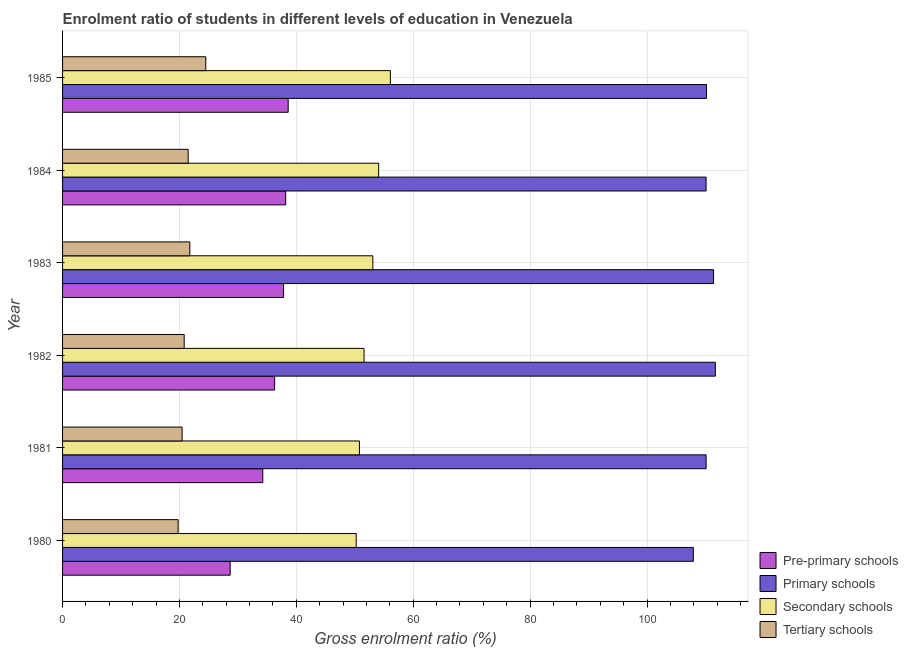How many groups of bars are there?
Provide a short and direct response. 6. How many bars are there on the 2nd tick from the bottom?
Your answer should be very brief. 4. What is the label of the 2nd group of bars from the top?
Your answer should be compact. 1984. What is the gross enrolment ratio in tertiary schools in 1984?
Offer a terse response. 21.5. Across all years, what is the maximum gross enrolment ratio in secondary schools?
Keep it short and to the point. 56.09. Across all years, what is the minimum gross enrolment ratio in tertiary schools?
Offer a very short reply. 19.77. In which year was the gross enrolment ratio in pre-primary schools maximum?
Keep it short and to the point. 1985. In which year was the gross enrolment ratio in pre-primary schools minimum?
Your response must be concise. 1980. What is the total gross enrolment ratio in tertiary schools in the graph?
Offer a very short reply. 128.81. What is the difference between the gross enrolment ratio in secondary schools in 1981 and that in 1983?
Make the answer very short. -2.3. What is the difference between the gross enrolment ratio in pre-primary schools in 1980 and the gross enrolment ratio in primary schools in 1985?
Ensure brevity in your answer.  -81.5. What is the average gross enrolment ratio in primary schools per year?
Your response must be concise. 110.24. In the year 1985, what is the difference between the gross enrolment ratio in tertiary schools and gross enrolment ratio in pre-primary schools?
Provide a succinct answer. -14.1. In how many years, is the gross enrolment ratio in pre-primary schools greater than 24 %?
Your answer should be very brief. 6. What is the ratio of the gross enrolment ratio in pre-primary schools in 1981 to that in 1982?
Offer a very short reply. 0.94. Is the gross enrolment ratio in pre-primary schools in 1981 less than that in 1985?
Provide a succinct answer. Yes. Is the difference between the gross enrolment ratio in pre-primary schools in 1983 and 1984 greater than the difference between the gross enrolment ratio in tertiary schools in 1983 and 1984?
Your answer should be very brief. No. What is the difference between the highest and the second highest gross enrolment ratio in pre-primary schools?
Offer a very short reply. 0.42. What is the difference between the highest and the lowest gross enrolment ratio in tertiary schools?
Give a very brief answer. 4.73. In how many years, is the gross enrolment ratio in pre-primary schools greater than the average gross enrolment ratio in pre-primary schools taken over all years?
Your answer should be compact. 4. What does the 1st bar from the top in 1985 represents?
Provide a succinct answer. Tertiary schools. What does the 3rd bar from the bottom in 1980 represents?
Offer a very short reply. Secondary schools. Are all the bars in the graph horizontal?
Ensure brevity in your answer.  Yes. How many years are there in the graph?
Offer a terse response. 6. What is the difference between two consecutive major ticks on the X-axis?
Make the answer very short. 20. Does the graph contain grids?
Provide a short and direct response. Yes. Where does the legend appear in the graph?
Your answer should be very brief. Bottom right. How are the legend labels stacked?
Keep it short and to the point. Vertical. What is the title of the graph?
Offer a very short reply. Enrolment ratio of students in different levels of education in Venezuela. What is the label or title of the X-axis?
Your answer should be very brief. Gross enrolment ratio (%). What is the label or title of the Y-axis?
Provide a succinct answer. Year. What is the Gross enrolment ratio (%) in Pre-primary schools in 1980?
Make the answer very short. 28.68. What is the Gross enrolment ratio (%) in Primary schools in 1980?
Provide a short and direct response. 107.93. What is the Gross enrolment ratio (%) of Secondary schools in 1980?
Offer a very short reply. 50.25. What is the Gross enrolment ratio (%) of Tertiary schools in 1980?
Your answer should be compact. 19.77. What is the Gross enrolment ratio (%) in Pre-primary schools in 1981?
Offer a terse response. 34.26. What is the Gross enrolment ratio (%) of Primary schools in 1981?
Give a very brief answer. 110.12. What is the Gross enrolment ratio (%) in Secondary schools in 1981?
Provide a succinct answer. 50.8. What is the Gross enrolment ratio (%) in Tertiary schools in 1981?
Provide a short and direct response. 20.45. What is the Gross enrolment ratio (%) in Pre-primary schools in 1982?
Make the answer very short. 36.28. What is the Gross enrolment ratio (%) of Primary schools in 1982?
Make the answer very short. 111.7. What is the Gross enrolment ratio (%) of Secondary schools in 1982?
Ensure brevity in your answer.  51.58. What is the Gross enrolment ratio (%) in Tertiary schools in 1982?
Provide a succinct answer. 20.81. What is the Gross enrolment ratio (%) of Pre-primary schools in 1983?
Make the answer very short. 37.82. What is the Gross enrolment ratio (%) in Primary schools in 1983?
Ensure brevity in your answer.  111.39. What is the Gross enrolment ratio (%) in Secondary schools in 1983?
Your answer should be very brief. 53.09. What is the Gross enrolment ratio (%) in Tertiary schools in 1983?
Your answer should be very brief. 21.77. What is the Gross enrolment ratio (%) in Pre-primary schools in 1984?
Provide a short and direct response. 38.18. What is the Gross enrolment ratio (%) in Primary schools in 1984?
Offer a terse response. 110.11. What is the Gross enrolment ratio (%) of Secondary schools in 1984?
Your answer should be very brief. 54.09. What is the Gross enrolment ratio (%) in Tertiary schools in 1984?
Your answer should be very brief. 21.5. What is the Gross enrolment ratio (%) in Pre-primary schools in 1985?
Make the answer very short. 38.61. What is the Gross enrolment ratio (%) of Primary schools in 1985?
Your answer should be compact. 110.18. What is the Gross enrolment ratio (%) in Secondary schools in 1985?
Your answer should be very brief. 56.09. What is the Gross enrolment ratio (%) of Tertiary schools in 1985?
Your answer should be compact. 24.51. Across all years, what is the maximum Gross enrolment ratio (%) in Pre-primary schools?
Give a very brief answer. 38.61. Across all years, what is the maximum Gross enrolment ratio (%) in Primary schools?
Give a very brief answer. 111.7. Across all years, what is the maximum Gross enrolment ratio (%) in Secondary schools?
Make the answer very short. 56.09. Across all years, what is the maximum Gross enrolment ratio (%) of Tertiary schools?
Keep it short and to the point. 24.51. Across all years, what is the minimum Gross enrolment ratio (%) in Pre-primary schools?
Provide a succinct answer. 28.68. Across all years, what is the minimum Gross enrolment ratio (%) of Primary schools?
Offer a terse response. 107.93. Across all years, what is the minimum Gross enrolment ratio (%) of Secondary schools?
Provide a succinct answer. 50.25. Across all years, what is the minimum Gross enrolment ratio (%) in Tertiary schools?
Make the answer very short. 19.77. What is the total Gross enrolment ratio (%) of Pre-primary schools in the graph?
Provide a short and direct response. 213.83. What is the total Gross enrolment ratio (%) of Primary schools in the graph?
Offer a very short reply. 661.43. What is the total Gross enrolment ratio (%) in Secondary schools in the graph?
Offer a terse response. 315.9. What is the total Gross enrolment ratio (%) of Tertiary schools in the graph?
Provide a succinct answer. 128.81. What is the difference between the Gross enrolment ratio (%) in Pre-primary schools in 1980 and that in 1981?
Ensure brevity in your answer.  -5.58. What is the difference between the Gross enrolment ratio (%) in Primary schools in 1980 and that in 1981?
Make the answer very short. -2.19. What is the difference between the Gross enrolment ratio (%) of Secondary schools in 1980 and that in 1981?
Your answer should be very brief. -0.55. What is the difference between the Gross enrolment ratio (%) of Tertiary schools in 1980 and that in 1981?
Your answer should be compact. -0.68. What is the difference between the Gross enrolment ratio (%) in Pre-primary schools in 1980 and that in 1982?
Ensure brevity in your answer.  -7.6. What is the difference between the Gross enrolment ratio (%) of Primary schools in 1980 and that in 1982?
Offer a terse response. -3.77. What is the difference between the Gross enrolment ratio (%) of Secondary schools in 1980 and that in 1982?
Ensure brevity in your answer.  -1.34. What is the difference between the Gross enrolment ratio (%) in Tertiary schools in 1980 and that in 1982?
Provide a succinct answer. -1.04. What is the difference between the Gross enrolment ratio (%) of Pre-primary schools in 1980 and that in 1983?
Ensure brevity in your answer.  -9.13. What is the difference between the Gross enrolment ratio (%) in Primary schools in 1980 and that in 1983?
Ensure brevity in your answer.  -3.45. What is the difference between the Gross enrolment ratio (%) of Secondary schools in 1980 and that in 1983?
Your answer should be compact. -2.84. What is the difference between the Gross enrolment ratio (%) of Tertiary schools in 1980 and that in 1983?
Your response must be concise. -2. What is the difference between the Gross enrolment ratio (%) in Pre-primary schools in 1980 and that in 1984?
Your answer should be very brief. -9.5. What is the difference between the Gross enrolment ratio (%) in Primary schools in 1980 and that in 1984?
Ensure brevity in your answer.  -2.18. What is the difference between the Gross enrolment ratio (%) in Secondary schools in 1980 and that in 1984?
Provide a short and direct response. -3.84. What is the difference between the Gross enrolment ratio (%) of Tertiary schools in 1980 and that in 1984?
Your answer should be compact. -1.72. What is the difference between the Gross enrolment ratio (%) in Pre-primary schools in 1980 and that in 1985?
Offer a terse response. -9.92. What is the difference between the Gross enrolment ratio (%) in Primary schools in 1980 and that in 1985?
Provide a short and direct response. -2.25. What is the difference between the Gross enrolment ratio (%) of Secondary schools in 1980 and that in 1985?
Keep it short and to the point. -5.85. What is the difference between the Gross enrolment ratio (%) in Tertiary schools in 1980 and that in 1985?
Keep it short and to the point. -4.73. What is the difference between the Gross enrolment ratio (%) of Pre-primary schools in 1981 and that in 1982?
Give a very brief answer. -2.03. What is the difference between the Gross enrolment ratio (%) of Primary schools in 1981 and that in 1982?
Offer a very short reply. -1.58. What is the difference between the Gross enrolment ratio (%) of Secondary schools in 1981 and that in 1982?
Offer a terse response. -0.79. What is the difference between the Gross enrolment ratio (%) of Tertiary schools in 1981 and that in 1982?
Your answer should be very brief. -0.36. What is the difference between the Gross enrolment ratio (%) of Pre-primary schools in 1981 and that in 1983?
Ensure brevity in your answer.  -3.56. What is the difference between the Gross enrolment ratio (%) in Primary schools in 1981 and that in 1983?
Provide a succinct answer. -1.27. What is the difference between the Gross enrolment ratio (%) of Secondary schools in 1981 and that in 1983?
Ensure brevity in your answer.  -2.3. What is the difference between the Gross enrolment ratio (%) of Tertiary schools in 1981 and that in 1983?
Make the answer very short. -1.32. What is the difference between the Gross enrolment ratio (%) in Pre-primary schools in 1981 and that in 1984?
Keep it short and to the point. -3.92. What is the difference between the Gross enrolment ratio (%) in Primary schools in 1981 and that in 1984?
Keep it short and to the point. 0.01. What is the difference between the Gross enrolment ratio (%) of Secondary schools in 1981 and that in 1984?
Provide a short and direct response. -3.29. What is the difference between the Gross enrolment ratio (%) in Tertiary schools in 1981 and that in 1984?
Ensure brevity in your answer.  -1.04. What is the difference between the Gross enrolment ratio (%) of Pre-primary schools in 1981 and that in 1985?
Your response must be concise. -4.35. What is the difference between the Gross enrolment ratio (%) of Primary schools in 1981 and that in 1985?
Your answer should be very brief. -0.06. What is the difference between the Gross enrolment ratio (%) of Secondary schools in 1981 and that in 1985?
Offer a terse response. -5.3. What is the difference between the Gross enrolment ratio (%) of Tertiary schools in 1981 and that in 1985?
Ensure brevity in your answer.  -4.05. What is the difference between the Gross enrolment ratio (%) of Pre-primary schools in 1982 and that in 1983?
Your answer should be compact. -1.53. What is the difference between the Gross enrolment ratio (%) of Primary schools in 1982 and that in 1983?
Ensure brevity in your answer.  0.32. What is the difference between the Gross enrolment ratio (%) in Secondary schools in 1982 and that in 1983?
Your answer should be compact. -1.51. What is the difference between the Gross enrolment ratio (%) of Tertiary schools in 1982 and that in 1983?
Ensure brevity in your answer.  -0.96. What is the difference between the Gross enrolment ratio (%) of Pre-primary schools in 1982 and that in 1984?
Ensure brevity in your answer.  -1.9. What is the difference between the Gross enrolment ratio (%) in Primary schools in 1982 and that in 1984?
Your answer should be compact. 1.59. What is the difference between the Gross enrolment ratio (%) in Secondary schools in 1982 and that in 1984?
Provide a succinct answer. -2.5. What is the difference between the Gross enrolment ratio (%) in Tertiary schools in 1982 and that in 1984?
Your answer should be compact. -0.69. What is the difference between the Gross enrolment ratio (%) in Pre-primary schools in 1982 and that in 1985?
Your response must be concise. -2.32. What is the difference between the Gross enrolment ratio (%) of Primary schools in 1982 and that in 1985?
Your answer should be very brief. 1.52. What is the difference between the Gross enrolment ratio (%) of Secondary schools in 1982 and that in 1985?
Ensure brevity in your answer.  -4.51. What is the difference between the Gross enrolment ratio (%) in Tertiary schools in 1982 and that in 1985?
Your answer should be compact. -3.7. What is the difference between the Gross enrolment ratio (%) of Pre-primary schools in 1983 and that in 1984?
Give a very brief answer. -0.36. What is the difference between the Gross enrolment ratio (%) in Primary schools in 1983 and that in 1984?
Offer a terse response. 1.28. What is the difference between the Gross enrolment ratio (%) in Secondary schools in 1983 and that in 1984?
Provide a succinct answer. -0.99. What is the difference between the Gross enrolment ratio (%) of Tertiary schools in 1983 and that in 1984?
Offer a terse response. 0.28. What is the difference between the Gross enrolment ratio (%) in Pre-primary schools in 1983 and that in 1985?
Keep it short and to the point. -0.79. What is the difference between the Gross enrolment ratio (%) of Primary schools in 1983 and that in 1985?
Your answer should be very brief. 1.21. What is the difference between the Gross enrolment ratio (%) in Secondary schools in 1983 and that in 1985?
Your response must be concise. -3. What is the difference between the Gross enrolment ratio (%) in Tertiary schools in 1983 and that in 1985?
Keep it short and to the point. -2.73. What is the difference between the Gross enrolment ratio (%) in Pre-primary schools in 1984 and that in 1985?
Offer a very short reply. -0.42. What is the difference between the Gross enrolment ratio (%) in Primary schools in 1984 and that in 1985?
Give a very brief answer. -0.07. What is the difference between the Gross enrolment ratio (%) in Secondary schools in 1984 and that in 1985?
Offer a terse response. -2.01. What is the difference between the Gross enrolment ratio (%) in Tertiary schools in 1984 and that in 1985?
Your answer should be very brief. -3.01. What is the difference between the Gross enrolment ratio (%) of Pre-primary schools in 1980 and the Gross enrolment ratio (%) of Primary schools in 1981?
Your answer should be very brief. -81.44. What is the difference between the Gross enrolment ratio (%) in Pre-primary schools in 1980 and the Gross enrolment ratio (%) in Secondary schools in 1981?
Provide a succinct answer. -22.11. What is the difference between the Gross enrolment ratio (%) in Pre-primary schools in 1980 and the Gross enrolment ratio (%) in Tertiary schools in 1981?
Your answer should be compact. 8.23. What is the difference between the Gross enrolment ratio (%) in Primary schools in 1980 and the Gross enrolment ratio (%) in Secondary schools in 1981?
Your response must be concise. 57.14. What is the difference between the Gross enrolment ratio (%) in Primary schools in 1980 and the Gross enrolment ratio (%) in Tertiary schools in 1981?
Ensure brevity in your answer.  87.48. What is the difference between the Gross enrolment ratio (%) in Secondary schools in 1980 and the Gross enrolment ratio (%) in Tertiary schools in 1981?
Keep it short and to the point. 29.8. What is the difference between the Gross enrolment ratio (%) in Pre-primary schools in 1980 and the Gross enrolment ratio (%) in Primary schools in 1982?
Make the answer very short. -83.02. What is the difference between the Gross enrolment ratio (%) in Pre-primary schools in 1980 and the Gross enrolment ratio (%) in Secondary schools in 1982?
Keep it short and to the point. -22.9. What is the difference between the Gross enrolment ratio (%) in Pre-primary schools in 1980 and the Gross enrolment ratio (%) in Tertiary schools in 1982?
Keep it short and to the point. 7.87. What is the difference between the Gross enrolment ratio (%) in Primary schools in 1980 and the Gross enrolment ratio (%) in Secondary schools in 1982?
Provide a succinct answer. 56.35. What is the difference between the Gross enrolment ratio (%) of Primary schools in 1980 and the Gross enrolment ratio (%) of Tertiary schools in 1982?
Your answer should be compact. 87.12. What is the difference between the Gross enrolment ratio (%) of Secondary schools in 1980 and the Gross enrolment ratio (%) of Tertiary schools in 1982?
Make the answer very short. 29.44. What is the difference between the Gross enrolment ratio (%) in Pre-primary schools in 1980 and the Gross enrolment ratio (%) in Primary schools in 1983?
Provide a succinct answer. -82.7. What is the difference between the Gross enrolment ratio (%) of Pre-primary schools in 1980 and the Gross enrolment ratio (%) of Secondary schools in 1983?
Give a very brief answer. -24.41. What is the difference between the Gross enrolment ratio (%) in Pre-primary schools in 1980 and the Gross enrolment ratio (%) in Tertiary schools in 1983?
Offer a terse response. 6.91. What is the difference between the Gross enrolment ratio (%) of Primary schools in 1980 and the Gross enrolment ratio (%) of Secondary schools in 1983?
Provide a short and direct response. 54.84. What is the difference between the Gross enrolment ratio (%) of Primary schools in 1980 and the Gross enrolment ratio (%) of Tertiary schools in 1983?
Your answer should be compact. 86.16. What is the difference between the Gross enrolment ratio (%) in Secondary schools in 1980 and the Gross enrolment ratio (%) in Tertiary schools in 1983?
Keep it short and to the point. 28.47. What is the difference between the Gross enrolment ratio (%) of Pre-primary schools in 1980 and the Gross enrolment ratio (%) of Primary schools in 1984?
Offer a very short reply. -81.43. What is the difference between the Gross enrolment ratio (%) of Pre-primary schools in 1980 and the Gross enrolment ratio (%) of Secondary schools in 1984?
Make the answer very short. -25.4. What is the difference between the Gross enrolment ratio (%) of Pre-primary schools in 1980 and the Gross enrolment ratio (%) of Tertiary schools in 1984?
Provide a succinct answer. 7.19. What is the difference between the Gross enrolment ratio (%) of Primary schools in 1980 and the Gross enrolment ratio (%) of Secondary schools in 1984?
Offer a terse response. 53.85. What is the difference between the Gross enrolment ratio (%) of Primary schools in 1980 and the Gross enrolment ratio (%) of Tertiary schools in 1984?
Your response must be concise. 86.44. What is the difference between the Gross enrolment ratio (%) in Secondary schools in 1980 and the Gross enrolment ratio (%) in Tertiary schools in 1984?
Your answer should be compact. 28.75. What is the difference between the Gross enrolment ratio (%) of Pre-primary schools in 1980 and the Gross enrolment ratio (%) of Primary schools in 1985?
Offer a terse response. -81.5. What is the difference between the Gross enrolment ratio (%) of Pre-primary schools in 1980 and the Gross enrolment ratio (%) of Secondary schools in 1985?
Your response must be concise. -27.41. What is the difference between the Gross enrolment ratio (%) of Pre-primary schools in 1980 and the Gross enrolment ratio (%) of Tertiary schools in 1985?
Offer a terse response. 4.18. What is the difference between the Gross enrolment ratio (%) of Primary schools in 1980 and the Gross enrolment ratio (%) of Secondary schools in 1985?
Make the answer very short. 51.84. What is the difference between the Gross enrolment ratio (%) in Primary schools in 1980 and the Gross enrolment ratio (%) in Tertiary schools in 1985?
Keep it short and to the point. 83.43. What is the difference between the Gross enrolment ratio (%) of Secondary schools in 1980 and the Gross enrolment ratio (%) of Tertiary schools in 1985?
Your answer should be compact. 25.74. What is the difference between the Gross enrolment ratio (%) in Pre-primary schools in 1981 and the Gross enrolment ratio (%) in Primary schools in 1982?
Give a very brief answer. -77.44. What is the difference between the Gross enrolment ratio (%) in Pre-primary schools in 1981 and the Gross enrolment ratio (%) in Secondary schools in 1982?
Make the answer very short. -17.33. What is the difference between the Gross enrolment ratio (%) in Pre-primary schools in 1981 and the Gross enrolment ratio (%) in Tertiary schools in 1982?
Your answer should be very brief. 13.45. What is the difference between the Gross enrolment ratio (%) in Primary schools in 1981 and the Gross enrolment ratio (%) in Secondary schools in 1982?
Your answer should be very brief. 58.53. What is the difference between the Gross enrolment ratio (%) in Primary schools in 1981 and the Gross enrolment ratio (%) in Tertiary schools in 1982?
Your answer should be very brief. 89.31. What is the difference between the Gross enrolment ratio (%) of Secondary schools in 1981 and the Gross enrolment ratio (%) of Tertiary schools in 1982?
Offer a very short reply. 29.99. What is the difference between the Gross enrolment ratio (%) of Pre-primary schools in 1981 and the Gross enrolment ratio (%) of Primary schools in 1983?
Your answer should be compact. -77.13. What is the difference between the Gross enrolment ratio (%) in Pre-primary schools in 1981 and the Gross enrolment ratio (%) in Secondary schools in 1983?
Provide a succinct answer. -18.83. What is the difference between the Gross enrolment ratio (%) of Pre-primary schools in 1981 and the Gross enrolment ratio (%) of Tertiary schools in 1983?
Make the answer very short. 12.48. What is the difference between the Gross enrolment ratio (%) of Primary schools in 1981 and the Gross enrolment ratio (%) of Secondary schools in 1983?
Your response must be concise. 57.03. What is the difference between the Gross enrolment ratio (%) of Primary schools in 1981 and the Gross enrolment ratio (%) of Tertiary schools in 1983?
Keep it short and to the point. 88.35. What is the difference between the Gross enrolment ratio (%) of Secondary schools in 1981 and the Gross enrolment ratio (%) of Tertiary schools in 1983?
Your response must be concise. 29.02. What is the difference between the Gross enrolment ratio (%) of Pre-primary schools in 1981 and the Gross enrolment ratio (%) of Primary schools in 1984?
Your response must be concise. -75.85. What is the difference between the Gross enrolment ratio (%) of Pre-primary schools in 1981 and the Gross enrolment ratio (%) of Secondary schools in 1984?
Ensure brevity in your answer.  -19.83. What is the difference between the Gross enrolment ratio (%) in Pre-primary schools in 1981 and the Gross enrolment ratio (%) in Tertiary schools in 1984?
Make the answer very short. 12.76. What is the difference between the Gross enrolment ratio (%) of Primary schools in 1981 and the Gross enrolment ratio (%) of Secondary schools in 1984?
Provide a short and direct response. 56.03. What is the difference between the Gross enrolment ratio (%) in Primary schools in 1981 and the Gross enrolment ratio (%) in Tertiary schools in 1984?
Your answer should be compact. 88.62. What is the difference between the Gross enrolment ratio (%) in Secondary schools in 1981 and the Gross enrolment ratio (%) in Tertiary schools in 1984?
Offer a very short reply. 29.3. What is the difference between the Gross enrolment ratio (%) in Pre-primary schools in 1981 and the Gross enrolment ratio (%) in Primary schools in 1985?
Give a very brief answer. -75.92. What is the difference between the Gross enrolment ratio (%) in Pre-primary schools in 1981 and the Gross enrolment ratio (%) in Secondary schools in 1985?
Offer a very short reply. -21.84. What is the difference between the Gross enrolment ratio (%) in Pre-primary schools in 1981 and the Gross enrolment ratio (%) in Tertiary schools in 1985?
Keep it short and to the point. 9.75. What is the difference between the Gross enrolment ratio (%) of Primary schools in 1981 and the Gross enrolment ratio (%) of Secondary schools in 1985?
Provide a short and direct response. 54.02. What is the difference between the Gross enrolment ratio (%) in Primary schools in 1981 and the Gross enrolment ratio (%) in Tertiary schools in 1985?
Keep it short and to the point. 85.61. What is the difference between the Gross enrolment ratio (%) of Secondary schools in 1981 and the Gross enrolment ratio (%) of Tertiary schools in 1985?
Keep it short and to the point. 26.29. What is the difference between the Gross enrolment ratio (%) in Pre-primary schools in 1982 and the Gross enrolment ratio (%) in Primary schools in 1983?
Provide a succinct answer. -75.1. What is the difference between the Gross enrolment ratio (%) in Pre-primary schools in 1982 and the Gross enrolment ratio (%) in Secondary schools in 1983?
Make the answer very short. -16.81. What is the difference between the Gross enrolment ratio (%) in Pre-primary schools in 1982 and the Gross enrolment ratio (%) in Tertiary schools in 1983?
Provide a short and direct response. 14.51. What is the difference between the Gross enrolment ratio (%) of Primary schools in 1982 and the Gross enrolment ratio (%) of Secondary schools in 1983?
Your answer should be very brief. 58.61. What is the difference between the Gross enrolment ratio (%) in Primary schools in 1982 and the Gross enrolment ratio (%) in Tertiary schools in 1983?
Offer a very short reply. 89.93. What is the difference between the Gross enrolment ratio (%) of Secondary schools in 1982 and the Gross enrolment ratio (%) of Tertiary schools in 1983?
Provide a short and direct response. 29.81. What is the difference between the Gross enrolment ratio (%) of Pre-primary schools in 1982 and the Gross enrolment ratio (%) of Primary schools in 1984?
Keep it short and to the point. -73.83. What is the difference between the Gross enrolment ratio (%) in Pre-primary schools in 1982 and the Gross enrolment ratio (%) in Secondary schools in 1984?
Give a very brief answer. -17.8. What is the difference between the Gross enrolment ratio (%) in Pre-primary schools in 1982 and the Gross enrolment ratio (%) in Tertiary schools in 1984?
Your answer should be compact. 14.79. What is the difference between the Gross enrolment ratio (%) in Primary schools in 1982 and the Gross enrolment ratio (%) in Secondary schools in 1984?
Give a very brief answer. 57.62. What is the difference between the Gross enrolment ratio (%) in Primary schools in 1982 and the Gross enrolment ratio (%) in Tertiary schools in 1984?
Your answer should be very brief. 90.21. What is the difference between the Gross enrolment ratio (%) of Secondary schools in 1982 and the Gross enrolment ratio (%) of Tertiary schools in 1984?
Make the answer very short. 30.09. What is the difference between the Gross enrolment ratio (%) of Pre-primary schools in 1982 and the Gross enrolment ratio (%) of Primary schools in 1985?
Offer a terse response. -73.89. What is the difference between the Gross enrolment ratio (%) of Pre-primary schools in 1982 and the Gross enrolment ratio (%) of Secondary schools in 1985?
Offer a very short reply. -19.81. What is the difference between the Gross enrolment ratio (%) in Pre-primary schools in 1982 and the Gross enrolment ratio (%) in Tertiary schools in 1985?
Your response must be concise. 11.78. What is the difference between the Gross enrolment ratio (%) of Primary schools in 1982 and the Gross enrolment ratio (%) of Secondary schools in 1985?
Provide a short and direct response. 55.61. What is the difference between the Gross enrolment ratio (%) of Primary schools in 1982 and the Gross enrolment ratio (%) of Tertiary schools in 1985?
Provide a short and direct response. 87.2. What is the difference between the Gross enrolment ratio (%) of Secondary schools in 1982 and the Gross enrolment ratio (%) of Tertiary schools in 1985?
Your answer should be very brief. 27.08. What is the difference between the Gross enrolment ratio (%) of Pre-primary schools in 1983 and the Gross enrolment ratio (%) of Primary schools in 1984?
Your answer should be very brief. -72.29. What is the difference between the Gross enrolment ratio (%) in Pre-primary schools in 1983 and the Gross enrolment ratio (%) in Secondary schools in 1984?
Your answer should be compact. -16.27. What is the difference between the Gross enrolment ratio (%) in Pre-primary schools in 1983 and the Gross enrolment ratio (%) in Tertiary schools in 1984?
Keep it short and to the point. 16.32. What is the difference between the Gross enrolment ratio (%) of Primary schools in 1983 and the Gross enrolment ratio (%) of Secondary schools in 1984?
Offer a terse response. 57.3. What is the difference between the Gross enrolment ratio (%) in Primary schools in 1983 and the Gross enrolment ratio (%) in Tertiary schools in 1984?
Offer a terse response. 89.89. What is the difference between the Gross enrolment ratio (%) of Secondary schools in 1983 and the Gross enrolment ratio (%) of Tertiary schools in 1984?
Keep it short and to the point. 31.6. What is the difference between the Gross enrolment ratio (%) in Pre-primary schools in 1983 and the Gross enrolment ratio (%) in Primary schools in 1985?
Provide a succinct answer. -72.36. What is the difference between the Gross enrolment ratio (%) of Pre-primary schools in 1983 and the Gross enrolment ratio (%) of Secondary schools in 1985?
Keep it short and to the point. -18.28. What is the difference between the Gross enrolment ratio (%) in Pre-primary schools in 1983 and the Gross enrolment ratio (%) in Tertiary schools in 1985?
Your answer should be compact. 13.31. What is the difference between the Gross enrolment ratio (%) of Primary schools in 1983 and the Gross enrolment ratio (%) of Secondary schools in 1985?
Ensure brevity in your answer.  55.29. What is the difference between the Gross enrolment ratio (%) of Primary schools in 1983 and the Gross enrolment ratio (%) of Tertiary schools in 1985?
Your answer should be very brief. 86.88. What is the difference between the Gross enrolment ratio (%) of Secondary schools in 1983 and the Gross enrolment ratio (%) of Tertiary schools in 1985?
Offer a very short reply. 28.59. What is the difference between the Gross enrolment ratio (%) of Pre-primary schools in 1984 and the Gross enrolment ratio (%) of Primary schools in 1985?
Your answer should be very brief. -72. What is the difference between the Gross enrolment ratio (%) in Pre-primary schools in 1984 and the Gross enrolment ratio (%) in Secondary schools in 1985?
Make the answer very short. -17.91. What is the difference between the Gross enrolment ratio (%) of Pre-primary schools in 1984 and the Gross enrolment ratio (%) of Tertiary schools in 1985?
Provide a short and direct response. 13.67. What is the difference between the Gross enrolment ratio (%) of Primary schools in 1984 and the Gross enrolment ratio (%) of Secondary schools in 1985?
Provide a succinct answer. 54.02. What is the difference between the Gross enrolment ratio (%) of Primary schools in 1984 and the Gross enrolment ratio (%) of Tertiary schools in 1985?
Provide a short and direct response. 85.6. What is the difference between the Gross enrolment ratio (%) in Secondary schools in 1984 and the Gross enrolment ratio (%) in Tertiary schools in 1985?
Give a very brief answer. 29.58. What is the average Gross enrolment ratio (%) in Pre-primary schools per year?
Offer a terse response. 35.64. What is the average Gross enrolment ratio (%) of Primary schools per year?
Give a very brief answer. 110.24. What is the average Gross enrolment ratio (%) in Secondary schools per year?
Ensure brevity in your answer.  52.65. What is the average Gross enrolment ratio (%) of Tertiary schools per year?
Your answer should be compact. 21.47. In the year 1980, what is the difference between the Gross enrolment ratio (%) of Pre-primary schools and Gross enrolment ratio (%) of Primary schools?
Your answer should be very brief. -79.25. In the year 1980, what is the difference between the Gross enrolment ratio (%) in Pre-primary schools and Gross enrolment ratio (%) in Secondary schools?
Offer a terse response. -21.57. In the year 1980, what is the difference between the Gross enrolment ratio (%) of Pre-primary schools and Gross enrolment ratio (%) of Tertiary schools?
Give a very brief answer. 8.91. In the year 1980, what is the difference between the Gross enrolment ratio (%) in Primary schools and Gross enrolment ratio (%) in Secondary schools?
Offer a very short reply. 57.69. In the year 1980, what is the difference between the Gross enrolment ratio (%) in Primary schools and Gross enrolment ratio (%) in Tertiary schools?
Give a very brief answer. 88.16. In the year 1980, what is the difference between the Gross enrolment ratio (%) of Secondary schools and Gross enrolment ratio (%) of Tertiary schools?
Offer a very short reply. 30.47. In the year 1981, what is the difference between the Gross enrolment ratio (%) in Pre-primary schools and Gross enrolment ratio (%) in Primary schools?
Give a very brief answer. -75.86. In the year 1981, what is the difference between the Gross enrolment ratio (%) of Pre-primary schools and Gross enrolment ratio (%) of Secondary schools?
Offer a terse response. -16.54. In the year 1981, what is the difference between the Gross enrolment ratio (%) of Pre-primary schools and Gross enrolment ratio (%) of Tertiary schools?
Provide a short and direct response. 13.81. In the year 1981, what is the difference between the Gross enrolment ratio (%) in Primary schools and Gross enrolment ratio (%) in Secondary schools?
Ensure brevity in your answer.  59.32. In the year 1981, what is the difference between the Gross enrolment ratio (%) in Primary schools and Gross enrolment ratio (%) in Tertiary schools?
Give a very brief answer. 89.67. In the year 1981, what is the difference between the Gross enrolment ratio (%) of Secondary schools and Gross enrolment ratio (%) of Tertiary schools?
Give a very brief answer. 30.34. In the year 1982, what is the difference between the Gross enrolment ratio (%) in Pre-primary schools and Gross enrolment ratio (%) in Primary schools?
Your response must be concise. -75.42. In the year 1982, what is the difference between the Gross enrolment ratio (%) in Pre-primary schools and Gross enrolment ratio (%) in Secondary schools?
Your answer should be very brief. -15.3. In the year 1982, what is the difference between the Gross enrolment ratio (%) in Pre-primary schools and Gross enrolment ratio (%) in Tertiary schools?
Provide a short and direct response. 15.47. In the year 1982, what is the difference between the Gross enrolment ratio (%) of Primary schools and Gross enrolment ratio (%) of Secondary schools?
Provide a succinct answer. 60.12. In the year 1982, what is the difference between the Gross enrolment ratio (%) in Primary schools and Gross enrolment ratio (%) in Tertiary schools?
Provide a short and direct response. 90.89. In the year 1982, what is the difference between the Gross enrolment ratio (%) of Secondary schools and Gross enrolment ratio (%) of Tertiary schools?
Your answer should be very brief. 30.78. In the year 1983, what is the difference between the Gross enrolment ratio (%) in Pre-primary schools and Gross enrolment ratio (%) in Primary schools?
Provide a short and direct response. -73.57. In the year 1983, what is the difference between the Gross enrolment ratio (%) in Pre-primary schools and Gross enrolment ratio (%) in Secondary schools?
Keep it short and to the point. -15.28. In the year 1983, what is the difference between the Gross enrolment ratio (%) of Pre-primary schools and Gross enrolment ratio (%) of Tertiary schools?
Provide a succinct answer. 16.04. In the year 1983, what is the difference between the Gross enrolment ratio (%) in Primary schools and Gross enrolment ratio (%) in Secondary schools?
Make the answer very short. 58.29. In the year 1983, what is the difference between the Gross enrolment ratio (%) of Primary schools and Gross enrolment ratio (%) of Tertiary schools?
Your answer should be compact. 89.61. In the year 1983, what is the difference between the Gross enrolment ratio (%) of Secondary schools and Gross enrolment ratio (%) of Tertiary schools?
Ensure brevity in your answer.  31.32. In the year 1984, what is the difference between the Gross enrolment ratio (%) of Pre-primary schools and Gross enrolment ratio (%) of Primary schools?
Provide a succinct answer. -71.93. In the year 1984, what is the difference between the Gross enrolment ratio (%) in Pre-primary schools and Gross enrolment ratio (%) in Secondary schools?
Give a very brief answer. -15.9. In the year 1984, what is the difference between the Gross enrolment ratio (%) of Pre-primary schools and Gross enrolment ratio (%) of Tertiary schools?
Give a very brief answer. 16.68. In the year 1984, what is the difference between the Gross enrolment ratio (%) in Primary schools and Gross enrolment ratio (%) in Secondary schools?
Provide a succinct answer. 56.02. In the year 1984, what is the difference between the Gross enrolment ratio (%) in Primary schools and Gross enrolment ratio (%) in Tertiary schools?
Your response must be concise. 88.61. In the year 1984, what is the difference between the Gross enrolment ratio (%) of Secondary schools and Gross enrolment ratio (%) of Tertiary schools?
Your answer should be very brief. 32.59. In the year 1985, what is the difference between the Gross enrolment ratio (%) in Pre-primary schools and Gross enrolment ratio (%) in Primary schools?
Your response must be concise. -71.57. In the year 1985, what is the difference between the Gross enrolment ratio (%) in Pre-primary schools and Gross enrolment ratio (%) in Secondary schools?
Offer a very short reply. -17.49. In the year 1985, what is the difference between the Gross enrolment ratio (%) in Pre-primary schools and Gross enrolment ratio (%) in Tertiary schools?
Give a very brief answer. 14.1. In the year 1985, what is the difference between the Gross enrolment ratio (%) of Primary schools and Gross enrolment ratio (%) of Secondary schools?
Offer a very short reply. 54.08. In the year 1985, what is the difference between the Gross enrolment ratio (%) in Primary schools and Gross enrolment ratio (%) in Tertiary schools?
Your response must be concise. 85.67. In the year 1985, what is the difference between the Gross enrolment ratio (%) of Secondary schools and Gross enrolment ratio (%) of Tertiary schools?
Make the answer very short. 31.59. What is the ratio of the Gross enrolment ratio (%) of Pre-primary schools in 1980 to that in 1981?
Provide a succinct answer. 0.84. What is the ratio of the Gross enrolment ratio (%) in Primary schools in 1980 to that in 1981?
Ensure brevity in your answer.  0.98. What is the ratio of the Gross enrolment ratio (%) in Tertiary schools in 1980 to that in 1981?
Give a very brief answer. 0.97. What is the ratio of the Gross enrolment ratio (%) in Pre-primary schools in 1980 to that in 1982?
Give a very brief answer. 0.79. What is the ratio of the Gross enrolment ratio (%) of Primary schools in 1980 to that in 1982?
Your answer should be very brief. 0.97. What is the ratio of the Gross enrolment ratio (%) of Secondary schools in 1980 to that in 1982?
Offer a very short reply. 0.97. What is the ratio of the Gross enrolment ratio (%) of Tertiary schools in 1980 to that in 1982?
Make the answer very short. 0.95. What is the ratio of the Gross enrolment ratio (%) in Pre-primary schools in 1980 to that in 1983?
Offer a terse response. 0.76. What is the ratio of the Gross enrolment ratio (%) in Secondary schools in 1980 to that in 1983?
Ensure brevity in your answer.  0.95. What is the ratio of the Gross enrolment ratio (%) in Tertiary schools in 1980 to that in 1983?
Provide a succinct answer. 0.91. What is the ratio of the Gross enrolment ratio (%) in Pre-primary schools in 1980 to that in 1984?
Keep it short and to the point. 0.75. What is the ratio of the Gross enrolment ratio (%) in Primary schools in 1980 to that in 1984?
Your response must be concise. 0.98. What is the ratio of the Gross enrolment ratio (%) in Secondary schools in 1980 to that in 1984?
Your answer should be very brief. 0.93. What is the ratio of the Gross enrolment ratio (%) of Tertiary schools in 1980 to that in 1984?
Make the answer very short. 0.92. What is the ratio of the Gross enrolment ratio (%) of Pre-primary schools in 1980 to that in 1985?
Provide a short and direct response. 0.74. What is the ratio of the Gross enrolment ratio (%) of Primary schools in 1980 to that in 1985?
Your response must be concise. 0.98. What is the ratio of the Gross enrolment ratio (%) of Secondary schools in 1980 to that in 1985?
Provide a succinct answer. 0.9. What is the ratio of the Gross enrolment ratio (%) in Tertiary schools in 1980 to that in 1985?
Offer a terse response. 0.81. What is the ratio of the Gross enrolment ratio (%) of Pre-primary schools in 1981 to that in 1982?
Your answer should be very brief. 0.94. What is the ratio of the Gross enrolment ratio (%) of Primary schools in 1981 to that in 1982?
Provide a succinct answer. 0.99. What is the ratio of the Gross enrolment ratio (%) of Secondary schools in 1981 to that in 1982?
Make the answer very short. 0.98. What is the ratio of the Gross enrolment ratio (%) in Tertiary schools in 1981 to that in 1982?
Make the answer very short. 0.98. What is the ratio of the Gross enrolment ratio (%) of Pre-primary schools in 1981 to that in 1983?
Your answer should be compact. 0.91. What is the ratio of the Gross enrolment ratio (%) in Primary schools in 1981 to that in 1983?
Ensure brevity in your answer.  0.99. What is the ratio of the Gross enrolment ratio (%) in Secondary schools in 1981 to that in 1983?
Offer a terse response. 0.96. What is the ratio of the Gross enrolment ratio (%) in Tertiary schools in 1981 to that in 1983?
Your answer should be compact. 0.94. What is the ratio of the Gross enrolment ratio (%) in Pre-primary schools in 1981 to that in 1984?
Your answer should be very brief. 0.9. What is the ratio of the Gross enrolment ratio (%) of Secondary schools in 1981 to that in 1984?
Offer a terse response. 0.94. What is the ratio of the Gross enrolment ratio (%) in Tertiary schools in 1981 to that in 1984?
Your answer should be very brief. 0.95. What is the ratio of the Gross enrolment ratio (%) in Pre-primary schools in 1981 to that in 1985?
Ensure brevity in your answer.  0.89. What is the ratio of the Gross enrolment ratio (%) in Primary schools in 1981 to that in 1985?
Your response must be concise. 1. What is the ratio of the Gross enrolment ratio (%) in Secondary schools in 1981 to that in 1985?
Offer a very short reply. 0.91. What is the ratio of the Gross enrolment ratio (%) of Tertiary schools in 1981 to that in 1985?
Provide a succinct answer. 0.83. What is the ratio of the Gross enrolment ratio (%) of Pre-primary schools in 1982 to that in 1983?
Your answer should be very brief. 0.96. What is the ratio of the Gross enrolment ratio (%) of Secondary schools in 1982 to that in 1983?
Keep it short and to the point. 0.97. What is the ratio of the Gross enrolment ratio (%) of Tertiary schools in 1982 to that in 1983?
Give a very brief answer. 0.96. What is the ratio of the Gross enrolment ratio (%) in Pre-primary schools in 1982 to that in 1984?
Keep it short and to the point. 0.95. What is the ratio of the Gross enrolment ratio (%) in Primary schools in 1982 to that in 1984?
Your answer should be very brief. 1.01. What is the ratio of the Gross enrolment ratio (%) of Secondary schools in 1982 to that in 1984?
Keep it short and to the point. 0.95. What is the ratio of the Gross enrolment ratio (%) in Tertiary schools in 1982 to that in 1984?
Provide a succinct answer. 0.97. What is the ratio of the Gross enrolment ratio (%) of Pre-primary schools in 1982 to that in 1985?
Provide a short and direct response. 0.94. What is the ratio of the Gross enrolment ratio (%) in Primary schools in 1982 to that in 1985?
Offer a very short reply. 1.01. What is the ratio of the Gross enrolment ratio (%) in Secondary schools in 1982 to that in 1985?
Your answer should be very brief. 0.92. What is the ratio of the Gross enrolment ratio (%) of Tertiary schools in 1982 to that in 1985?
Your answer should be very brief. 0.85. What is the ratio of the Gross enrolment ratio (%) in Primary schools in 1983 to that in 1984?
Give a very brief answer. 1.01. What is the ratio of the Gross enrolment ratio (%) of Secondary schools in 1983 to that in 1984?
Make the answer very short. 0.98. What is the ratio of the Gross enrolment ratio (%) of Tertiary schools in 1983 to that in 1984?
Your answer should be very brief. 1.01. What is the ratio of the Gross enrolment ratio (%) of Pre-primary schools in 1983 to that in 1985?
Offer a terse response. 0.98. What is the ratio of the Gross enrolment ratio (%) in Secondary schools in 1983 to that in 1985?
Your answer should be very brief. 0.95. What is the ratio of the Gross enrolment ratio (%) of Tertiary schools in 1983 to that in 1985?
Your response must be concise. 0.89. What is the ratio of the Gross enrolment ratio (%) of Secondary schools in 1984 to that in 1985?
Your response must be concise. 0.96. What is the ratio of the Gross enrolment ratio (%) in Tertiary schools in 1984 to that in 1985?
Provide a succinct answer. 0.88. What is the difference between the highest and the second highest Gross enrolment ratio (%) in Pre-primary schools?
Give a very brief answer. 0.42. What is the difference between the highest and the second highest Gross enrolment ratio (%) of Primary schools?
Your answer should be very brief. 0.32. What is the difference between the highest and the second highest Gross enrolment ratio (%) in Secondary schools?
Keep it short and to the point. 2.01. What is the difference between the highest and the second highest Gross enrolment ratio (%) in Tertiary schools?
Keep it short and to the point. 2.73. What is the difference between the highest and the lowest Gross enrolment ratio (%) in Pre-primary schools?
Provide a short and direct response. 9.92. What is the difference between the highest and the lowest Gross enrolment ratio (%) in Primary schools?
Provide a short and direct response. 3.77. What is the difference between the highest and the lowest Gross enrolment ratio (%) in Secondary schools?
Ensure brevity in your answer.  5.85. What is the difference between the highest and the lowest Gross enrolment ratio (%) of Tertiary schools?
Make the answer very short. 4.73. 